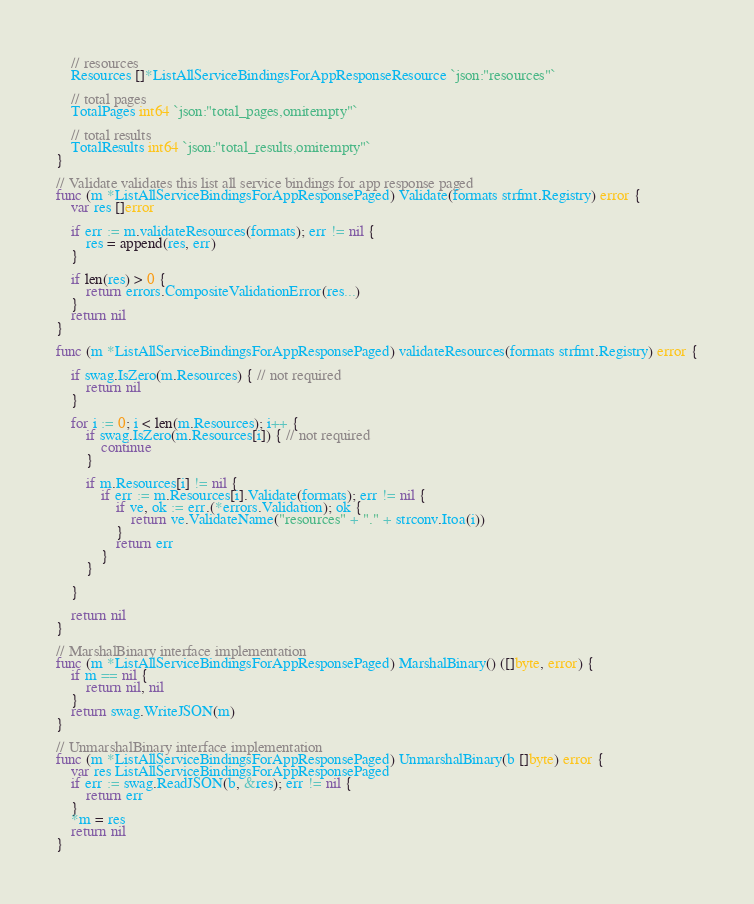<code> <loc_0><loc_0><loc_500><loc_500><_Go_>	// resources
	Resources []*ListAllServiceBindingsForAppResponseResource `json:"resources"`

	// total pages
	TotalPages int64 `json:"total_pages,omitempty"`

	// total results
	TotalResults int64 `json:"total_results,omitempty"`
}

// Validate validates this list all service bindings for app response paged
func (m *ListAllServiceBindingsForAppResponsePaged) Validate(formats strfmt.Registry) error {
	var res []error

	if err := m.validateResources(formats); err != nil {
		res = append(res, err)
	}

	if len(res) > 0 {
		return errors.CompositeValidationError(res...)
	}
	return nil
}

func (m *ListAllServiceBindingsForAppResponsePaged) validateResources(formats strfmt.Registry) error {

	if swag.IsZero(m.Resources) { // not required
		return nil
	}

	for i := 0; i < len(m.Resources); i++ {
		if swag.IsZero(m.Resources[i]) { // not required
			continue
		}

		if m.Resources[i] != nil {
			if err := m.Resources[i].Validate(formats); err != nil {
				if ve, ok := err.(*errors.Validation); ok {
					return ve.ValidateName("resources" + "." + strconv.Itoa(i))
				}
				return err
			}
		}

	}

	return nil
}

// MarshalBinary interface implementation
func (m *ListAllServiceBindingsForAppResponsePaged) MarshalBinary() ([]byte, error) {
	if m == nil {
		return nil, nil
	}
	return swag.WriteJSON(m)
}

// UnmarshalBinary interface implementation
func (m *ListAllServiceBindingsForAppResponsePaged) UnmarshalBinary(b []byte) error {
	var res ListAllServiceBindingsForAppResponsePaged
	if err := swag.ReadJSON(b, &res); err != nil {
		return err
	}
	*m = res
	return nil
}
</code> 